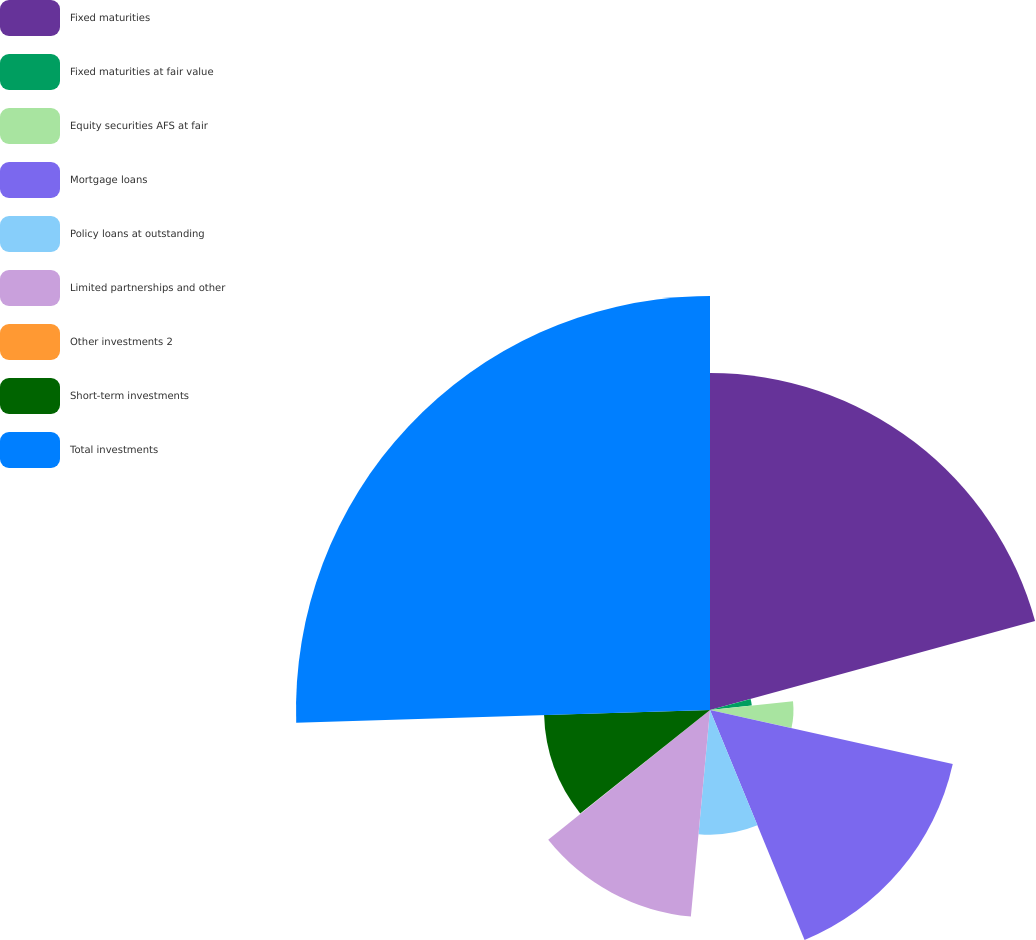Convert chart to OTSL. <chart><loc_0><loc_0><loc_500><loc_500><pie_chart><fcel>Fixed maturities<fcel>Fixed maturities at fair value<fcel>Equity securities AFS at fair<fcel>Mortgage loans<fcel>Policy loans at outstanding<fcel>Limited partnerships and other<fcel>Other investments 2<fcel>Short-term investments<fcel>Total investments<nl><fcel>20.75%<fcel>2.59%<fcel>5.14%<fcel>15.31%<fcel>7.68%<fcel>12.77%<fcel>0.05%<fcel>10.22%<fcel>25.49%<nl></chart> 